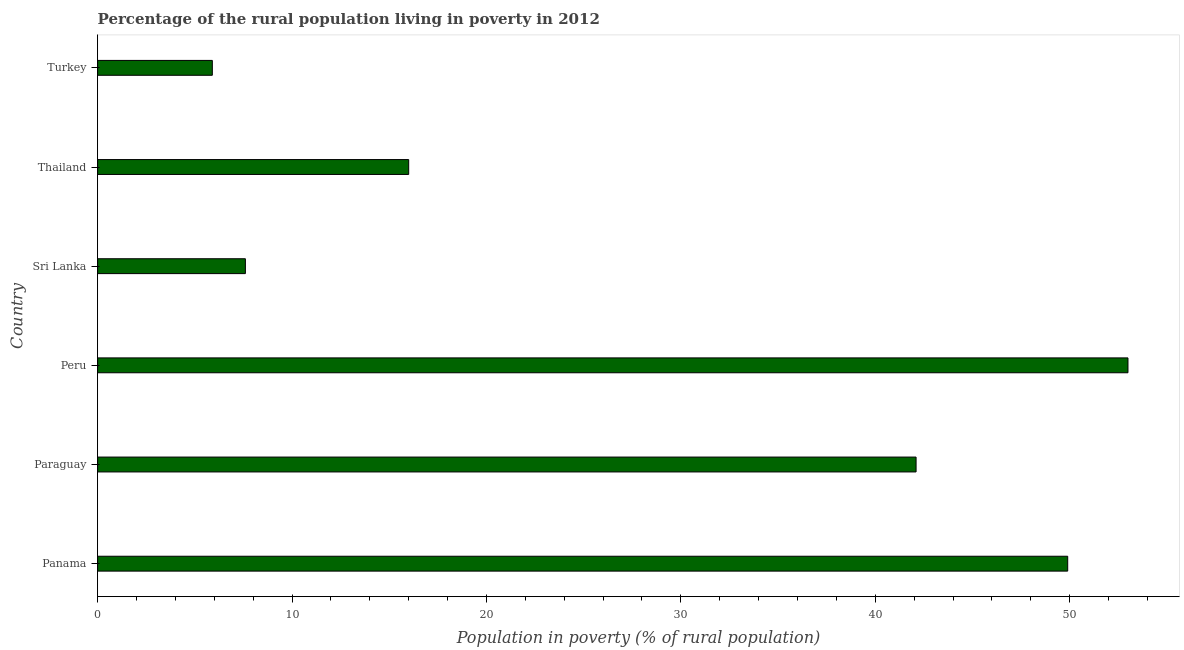Does the graph contain any zero values?
Offer a terse response. No. Does the graph contain grids?
Your answer should be compact. No. What is the title of the graph?
Your response must be concise. Percentage of the rural population living in poverty in 2012. What is the label or title of the X-axis?
Give a very brief answer. Population in poverty (% of rural population). What is the label or title of the Y-axis?
Provide a succinct answer. Country. What is the sum of the percentage of rural population living below poverty line?
Provide a short and direct response. 174.5. What is the difference between the percentage of rural population living below poverty line in Paraguay and Turkey?
Your response must be concise. 36.2. What is the average percentage of rural population living below poverty line per country?
Your answer should be compact. 29.08. What is the median percentage of rural population living below poverty line?
Provide a succinct answer. 29.05. What is the ratio of the percentage of rural population living below poverty line in Peru to that in Thailand?
Your answer should be compact. 3.31. Is the difference between the percentage of rural population living below poverty line in Sri Lanka and Turkey greater than the difference between any two countries?
Give a very brief answer. No. Is the sum of the percentage of rural population living below poverty line in Sri Lanka and Thailand greater than the maximum percentage of rural population living below poverty line across all countries?
Offer a very short reply. No. What is the difference between the highest and the lowest percentage of rural population living below poverty line?
Offer a very short reply. 47.1. Are the values on the major ticks of X-axis written in scientific E-notation?
Your answer should be very brief. No. What is the Population in poverty (% of rural population) of Panama?
Offer a very short reply. 49.9. What is the Population in poverty (% of rural population) in Paraguay?
Keep it short and to the point. 42.1. What is the difference between the Population in poverty (% of rural population) in Panama and Sri Lanka?
Give a very brief answer. 42.3. What is the difference between the Population in poverty (% of rural population) in Panama and Thailand?
Your response must be concise. 33.9. What is the difference between the Population in poverty (% of rural population) in Paraguay and Sri Lanka?
Ensure brevity in your answer.  34.5. What is the difference between the Population in poverty (% of rural population) in Paraguay and Thailand?
Provide a short and direct response. 26.1. What is the difference between the Population in poverty (% of rural population) in Paraguay and Turkey?
Offer a terse response. 36.2. What is the difference between the Population in poverty (% of rural population) in Peru and Sri Lanka?
Provide a succinct answer. 45.4. What is the difference between the Population in poverty (% of rural population) in Peru and Thailand?
Provide a succinct answer. 37. What is the difference between the Population in poverty (% of rural population) in Peru and Turkey?
Provide a short and direct response. 47.1. What is the difference between the Population in poverty (% of rural population) in Sri Lanka and Thailand?
Provide a short and direct response. -8.4. What is the difference between the Population in poverty (% of rural population) in Sri Lanka and Turkey?
Your answer should be compact. 1.7. What is the ratio of the Population in poverty (% of rural population) in Panama to that in Paraguay?
Provide a short and direct response. 1.19. What is the ratio of the Population in poverty (% of rural population) in Panama to that in Peru?
Offer a very short reply. 0.94. What is the ratio of the Population in poverty (% of rural population) in Panama to that in Sri Lanka?
Provide a succinct answer. 6.57. What is the ratio of the Population in poverty (% of rural population) in Panama to that in Thailand?
Make the answer very short. 3.12. What is the ratio of the Population in poverty (% of rural population) in Panama to that in Turkey?
Provide a succinct answer. 8.46. What is the ratio of the Population in poverty (% of rural population) in Paraguay to that in Peru?
Make the answer very short. 0.79. What is the ratio of the Population in poverty (% of rural population) in Paraguay to that in Sri Lanka?
Your response must be concise. 5.54. What is the ratio of the Population in poverty (% of rural population) in Paraguay to that in Thailand?
Keep it short and to the point. 2.63. What is the ratio of the Population in poverty (% of rural population) in Paraguay to that in Turkey?
Your answer should be very brief. 7.14. What is the ratio of the Population in poverty (% of rural population) in Peru to that in Sri Lanka?
Give a very brief answer. 6.97. What is the ratio of the Population in poverty (% of rural population) in Peru to that in Thailand?
Your answer should be very brief. 3.31. What is the ratio of the Population in poverty (% of rural population) in Peru to that in Turkey?
Offer a terse response. 8.98. What is the ratio of the Population in poverty (% of rural population) in Sri Lanka to that in Thailand?
Keep it short and to the point. 0.47. What is the ratio of the Population in poverty (% of rural population) in Sri Lanka to that in Turkey?
Keep it short and to the point. 1.29. What is the ratio of the Population in poverty (% of rural population) in Thailand to that in Turkey?
Offer a very short reply. 2.71. 